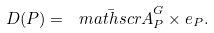Convert formula to latex. <formula><loc_0><loc_0><loc_500><loc_500>D ( P ) = \bar { \ m a t h s c r A } _ { P } ^ { G } \times e _ { P } .</formula> 